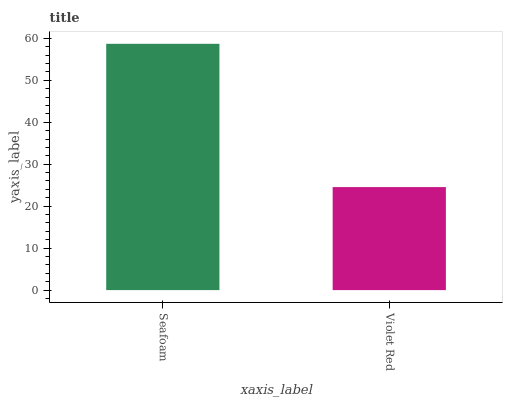Is Violet Red the minimum?
Answer yes or no. Yes. Is Seafoam the maximum?
Answer yes or no. Yes. Is Violet Red the maximum?
Answer yes or no. No. Is Seafoam greater than Violet Red?
Answer yes or no. Yes. Is Violet Red less than Seafoam?
Answer yes or no. Yes. Is Violet Red greater than Seafoam?
Answer yes or no. No. Is Seafoam less than Violet Red?
Answer yes or no. No. Is Seafoam the high median?
Answer yes or no. Yes. Is Violet Red the low median?
Answer yes or no. Yes. Is Violet Red the high median?
Answer yes or no. No. Is Seafoam the low median?
Answer yes or no. No. 